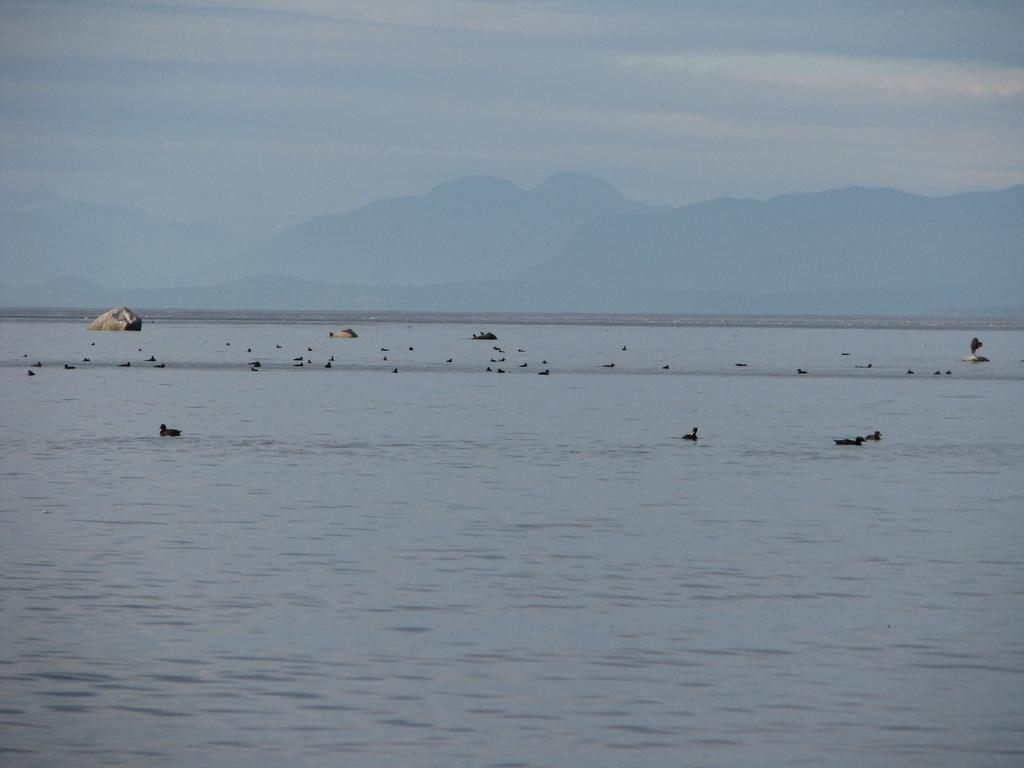What type of natural environment is depicted in the image? There is a sea in the image. What animals can be seen near the sea? There are birds near the sea. What geographical feature is visible in the background of the image? There are mountains visible in the background of the image. What is visible at the top of the image? The sky is visible at the top of the image. How does the sea fall on the side of the mountains in the image? The sea does not fall on the side of the mountains in the image; it is a separate body of water. 